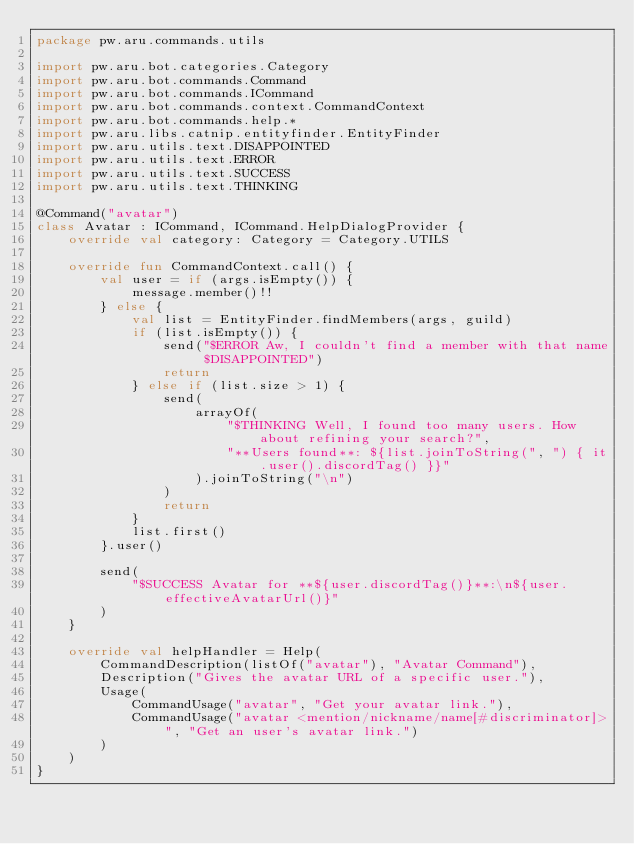Convert code to text. <code><loc_0><loc_0><loc_500><loc_500><_Kotlin_>package pw.aru.commands.utils

import pw.aru.bot.categories.Category
import pw.aru.bot.commands.Command
import pw.aru.bot.commands.ICommand
import pw.aru.bot.commands.context.CommandContext
import pw.aru.bot.commands.help.*
import pw.aru.libs.catnip.entityfinder.EntityFinder
import pw.aru.utils.text.DISAPPOINTED
import pw.aru.utils.text.ERROR
import pw.aru.utils.text.SUCCESS
import pw.aru.utils.text.THINKING

@Command("avatar")
class Avatar : ICommand, ICommand.HelpDialogProvider {
    override val category: Category = Category.UTILS

    override fun CommandContext.call() {
        val user = if (args.isEmpty()) {
            message.member()!!
        } else {
            val list = EntityFinder.findMembers(args, guild)
            if (list.isEmpty()) {
                send("$ERROR Aw, I couldn't find a member with that name $DISAPPOINTED")
                return
            } else if (list.size > 1) {
                send(
                    arrayOf(
                        "$THINKING Well, I found too many users. How about refining your search?",
                        "**Users found**: ${list.joinToString(", ") { it.user().discordTag() }}"
                    ).joinToString("\n")
                )
                return
            }
            list.first()
        }.user()

        send(
            "$SUCCESS Avatar for **${user.discordTag()}**:\n${user.effectiveAvatarUrl()}"
        )
    }

    override val helpHandler = Help(
        CommandDescription(listOf("avatar"), "Avatar Command"),
        Description("Gives the avatar URL of a specific user."),
        Usage(
            CommandUsage("avatar", "Get your avatar link."),
            CommandUsage("avatar <mention/nickname/name[#discriminator]>", "Get an user's avatar link.")
        )
    )
}</code> 